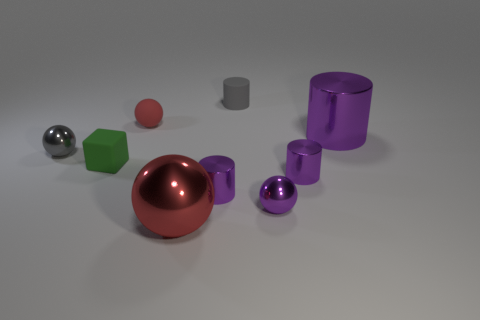Is the large metal ball the same color as the matte sphere?
Your response must be concise. Yes. What is the shape of the shiny thing that is left of the small purple shiny sphere and right of the red metal object?
Your answer should be very brief. Cylinder. What number of cyan objects are large metallic spheres or large cylinders?
Your response must be concise. 0. There is a large object that is in front of the big purple metallic cylinder; does it have the same color as the tiny matte ball?
Your answer should be very brief. Yes. What size is the red sphere to the left of the big object on the left side of the gray rubber object?
Your answer should be compact. Small. What material is the purple ball that is the same size as the gray sphere?
Ensure brevity in your answer.  Metal. How many other things are the same size as the gray ball?
Your answer should be very brief. 6. What number of blocks are tiny purple objects or gray rubber things?
Make the answer very short. 0. There is a tiny gray object in front of the purple metal cylinder behind the small metal sphere on the left side of the tiny green cube; what is its material?
Provide a short and direct response. Metal. There is a thing that is the same color as the rubber ball; what is it made of?
Ensure brevity in your answer.  Metal. 